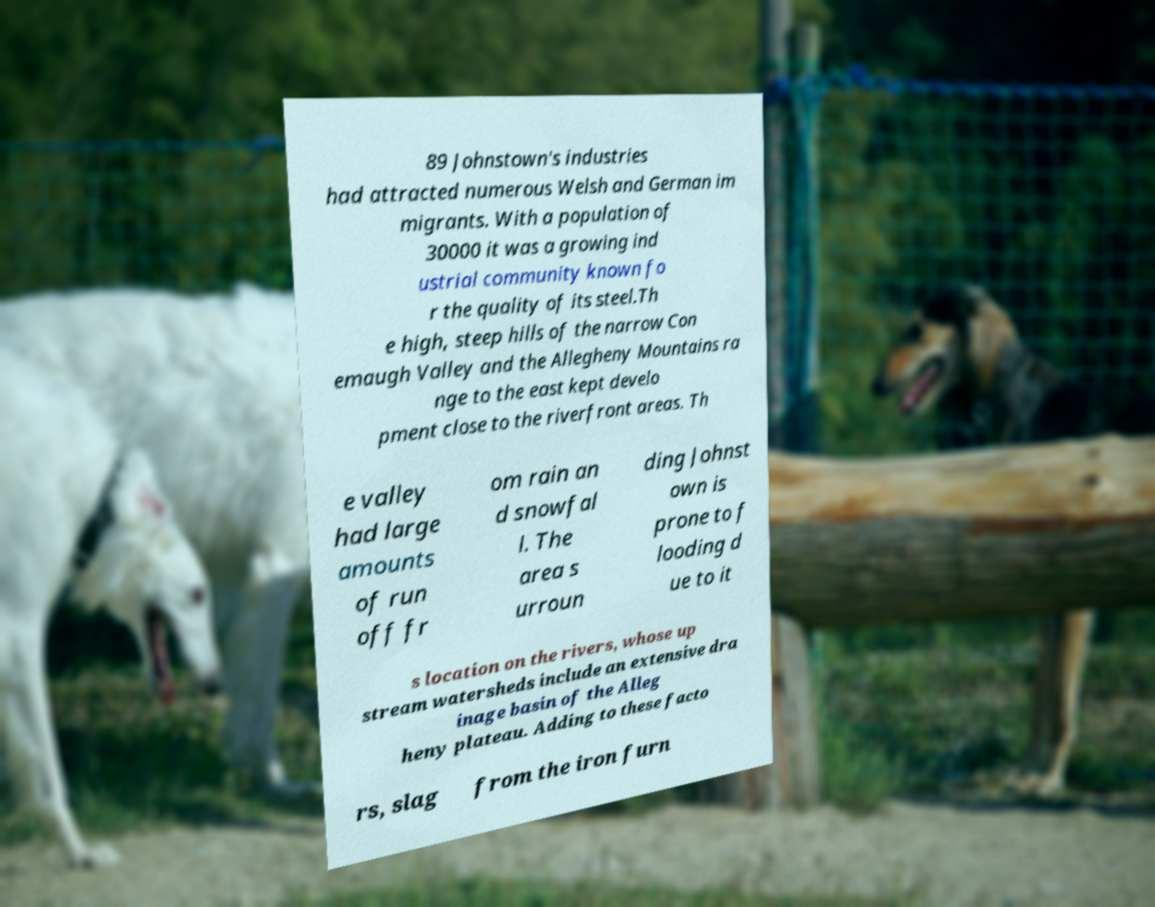What messages or text are displayed in this image? I need them in a readable, typed format. 89 Johnstown's industries had attracted numerous Welsh and German im migrants. With a population of 30000 it was a growing ind ustrial community known fo r the quality of its steel.Th e high, steep hills of the narrow Con emaugh Valley and the Allegheny Mountains ra nge to the east kept develo pment close to the riverfront areas. Th e valley had large amounts of run off fr om rain an d snowfal l. The area s urroun ding Johnst own is prone to f looding d ue to it s location on the rivers, whose up stream watersheds include an extensive dra inage basin of the Alleg heny plateau. Adding to these facto rs, slag from the iron furn 